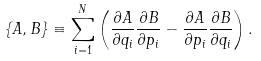<formula> <loc_0><loc_0><loc_500><loc_500>\left \{ A , B \right \} \equiv \sum _ { i = 1 } ^ { N } \left ( \frac { \partial A } { \partial q _ { i } } \frac { \partial B } { \partial p _ { i } } - \frac { \partial A } { \partial p _ { i } } \frac { \partial B } { \partial q _ { i } } \right ) .</formula> 